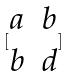Convert formula to latex. <formula><loc_0><loc_0><loc_500><loc_500>[ \begin{matrix} a & b \\ b & d \end{matrix} ]</formula> 